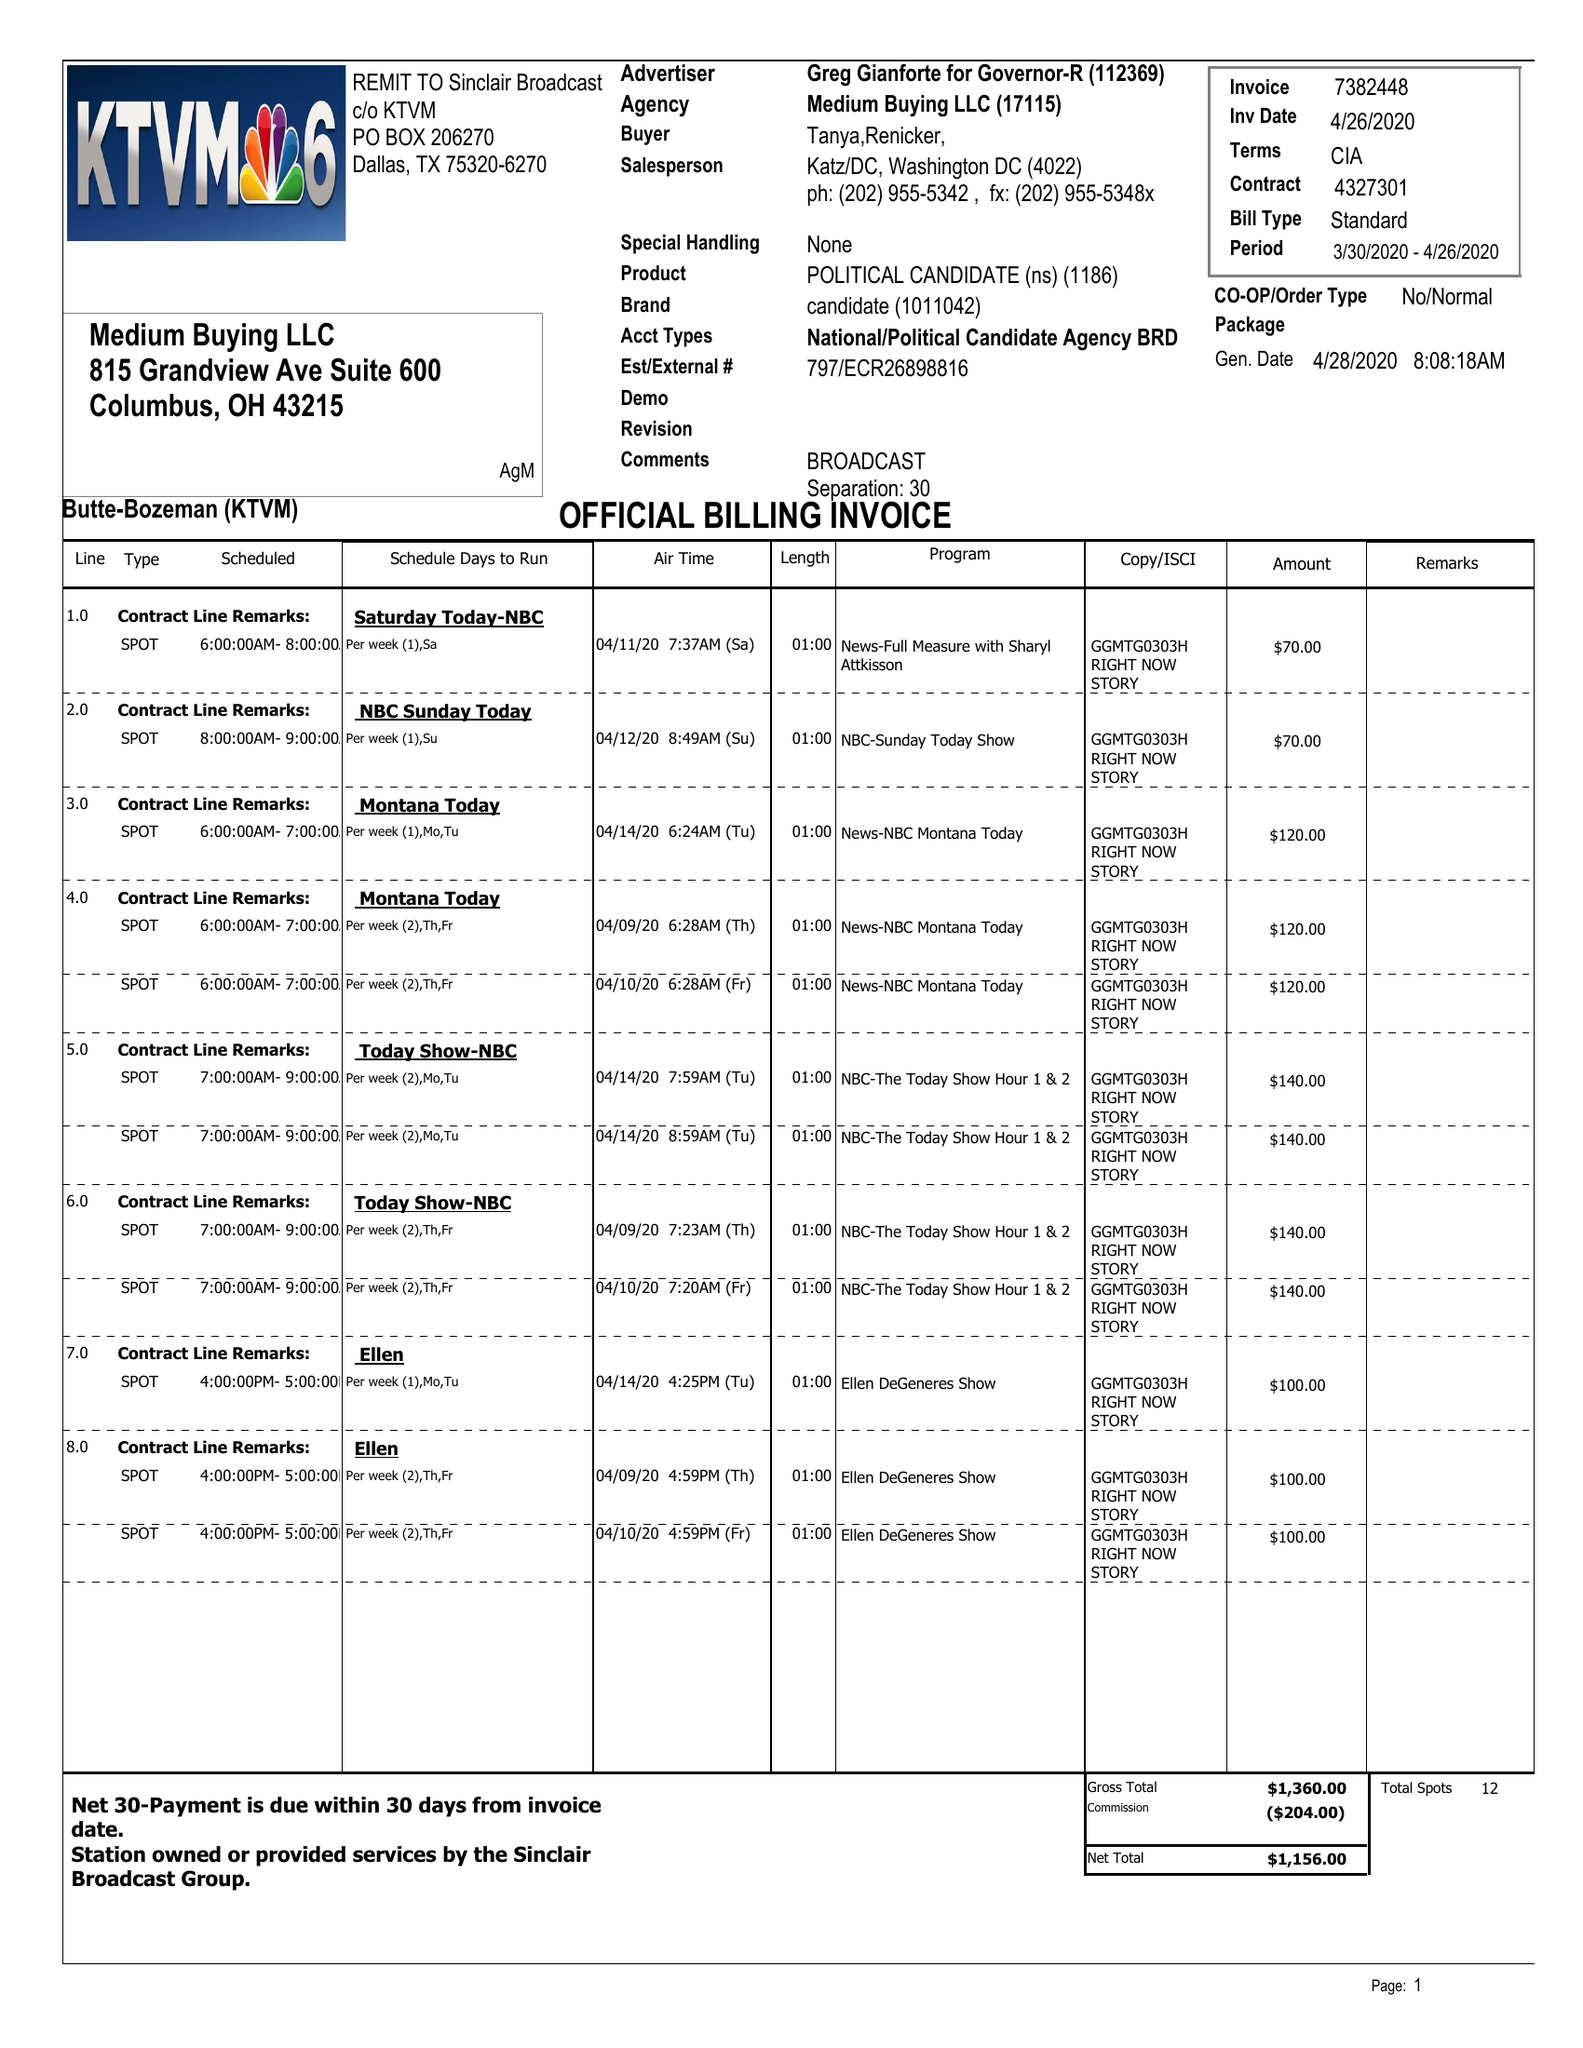What is the value for the contract_num?
Answer the question using a single word or phrase. 4327301 